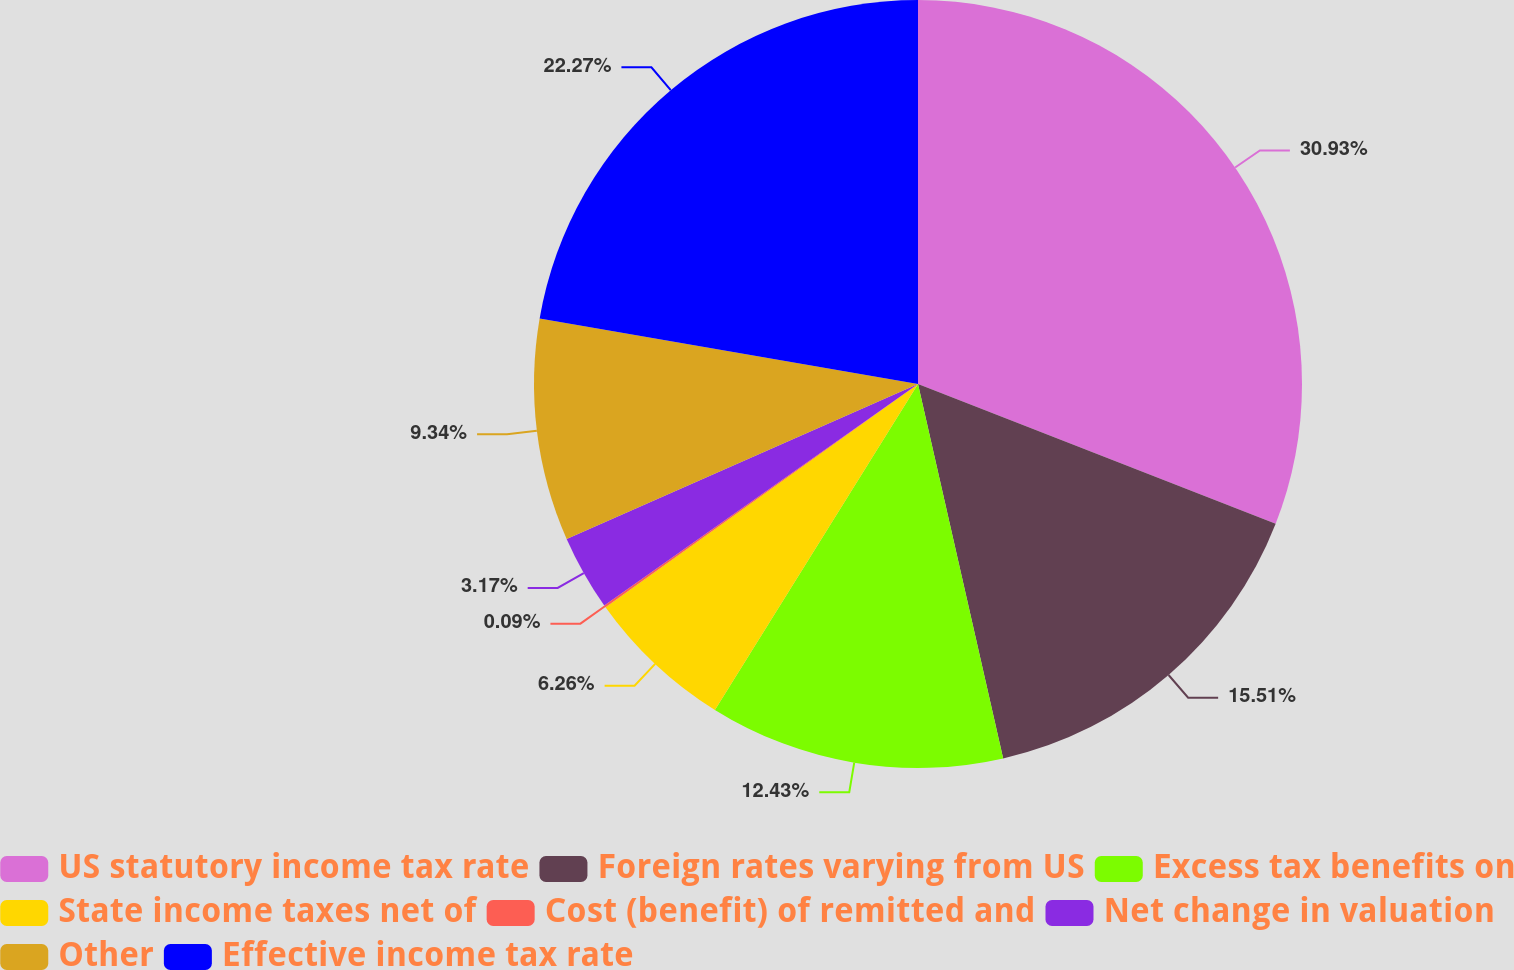<chart> <loc_0><loc_0><loc_500><loc_500><pie_chart><fcel>US statutory income tax rate<fcel>Foreign rates varying from US<fcel>Excess tax benefits on<fcel>State income taxes net of<fcel>Cost (benefit) of remitted and<fcel>Net change in valuation<fcel>Other<fcel>Effective income tax rate<nl><fcel>30.93%<fcel>15.51%<fcel>12.43%<fcel>6.26%<fcel>0.09%<fcel>3.17%<fcel>9.34%<fcel>22.27%<nl></chart> 